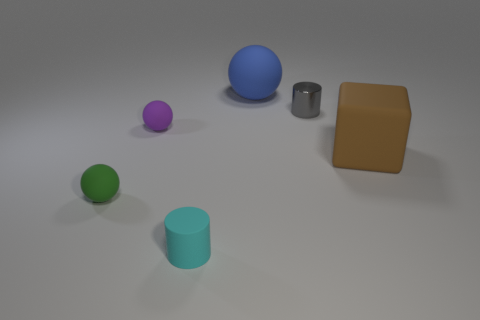How many tiny rubber objects are both on the right side of the purple object and behind the brown matte thing?
Give a very brief answer. 0. Does the gray metal cylinder have the same size as the blue object?
Give a very brief answer. No. There is a cylinder in front of the brown matte object; is it the same size as the green sphere?
Provide a succinct answer. Yes. There is a small cylinder that is behind the purple sphere; what is its color?
Give a very brief answer. Gray. How many blue spheres are there?
Your answer should be compact. 1. The purple thing that is made of the same material as the small green sphere is what shape?
Your answer should be very brief. Sphere. There is a big thing that is in front of the small gray metallic cylinder; is it the same color as the tiny cylinder on the left side of the large blue object?
Provide a succinct answer. No. Are there the same number of small objects that are behind the green sphere and small purple balls?
Your answer should be very brief. No. What number of matte balls are behind the rubber block?
Offer a terse response. 2. What is the size of the gray thing?
Offer a very short reply. Small. 